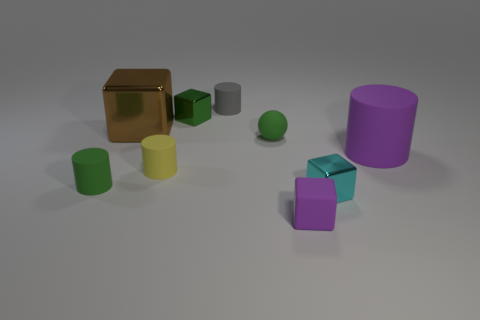What number of metal cubes are right of the big cube and behind the small rubber sphere?
Your answer should be compact. 1. How many tiny cylinders are right of the tiny cube that is behind the purple object to the right of the tiny purple block?
Your answer should be very brief. 1. There is a metallic cube that is the same color as the small rubber ball; what is its size?
Keep it short and to the point. Small. There is a cyan thing; what shape is it?
Offer a very short reply. Cube. What number of cubes have the same material as the brown thing?
Your response must be concise. 2. What is the color of the tiny block that is made of the same material as the big purple cylinder?
Make the answer very short. Purple. Is the size of the purple rubber cylinder the same as the brown object on the left side of the small purple cube?
Your answer should be very brief. Yes. What material is the object right of the block on the right side of the small rubber thing that is in front of the small green matte cylinder?
Provide a succinct answer. Rubber. What number of things are either brown spheres or large purple rubber cylinders?
Keep it short and to the point. 1. There is a rubber thing in front of the green matte cylinder; does it have the same color as the big thing that is in front of the brown thing?
Your answer should be very brief. Yes. 